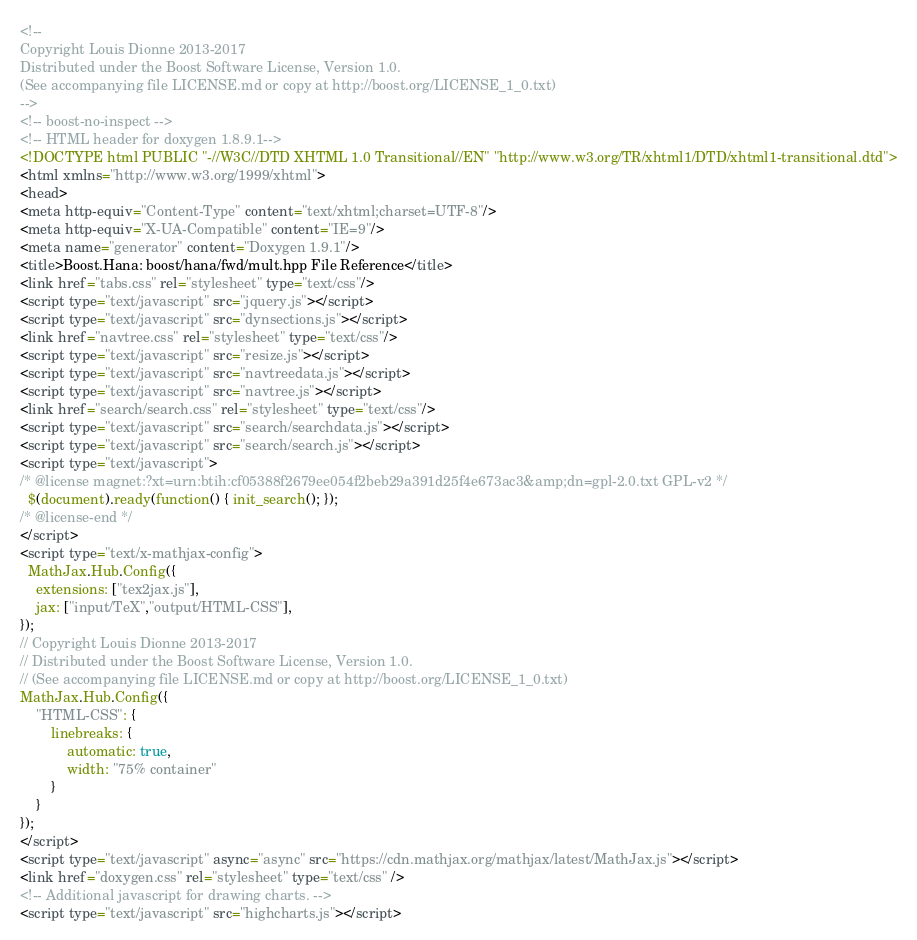<code> <loc_0><loc_0><loc_500><loc_500><_HTML_><!--
Copyright Louis Dionne 2013-2017
Distributed under the Boost Software License, Version 1.0.
(See accompanying file LICENSE.md or copy at http://boost.org/LICENSE_1_0.txt)
-->
<!-- boost-no-inspect -->
<!-- HTML header for doxygen 1.8.9.1-->
<!DOCTYPE html PUBLIC "-//W3C//DTD XHTML 1.0 Transitional//EN" "http://www.w3.org/TR/xhtml1/DTD/xhtml1-transitional.dtd">
<html xmlns="http://www.w3.org/1999/xhtml">
<head>
<meta http-equiv="Content-Type" content="text/xhtml;charset=UTF-8"/>
<meta http-equiv="X-UA-Compatible" content="IE=9"/>
<meta name="generator" content="Doxygen 1.9.1"/>
<title>Boost.Hana: boost/hana/fwd/mult.hpp File Reference</title>
<link href="tabs.css" rel="stylesheet" type="text/css"/>
<script type="text/javascript" src="jquery.js"></script>
<script type="text/javascript" src="dynsections.js"></script>
<link href="navtree.css" rel="stylesheet" type="text/css"/>
<script type="text/javascript" src="resize.js"></script>
<script type="text/javascript" src="navtreedata.js"></script>
<script type="text/javascript" src="navtree.js"></script>
<link href="search/search.css" rel="stylesheet" type="text/css"/>
<script type="text/javascript" src="search/searchdata.js"></script>
<script type="text/javascript" src="search/search.js"></script>
<script type="text/javascript">
/* @license magnet:?xt=urn:btih:cf05388f2679ee054f2beb29a391d25f4e673ac3&amp;dn=gpl-2.0.txt GPL-v2 */
  $(document).ready(function() { init_search(); });
/* @license-end */
</script>
<script type="text/x-mathjax-config">
  MathJax.Hub.Config({
    extensions: ["tex2jax.js"],
    jax: ["input/TeX","output/HTML-CSS"],
});
// Copyright Louis Dionne 2013-2017
// Distributed under the Boost Software License, Version 1.0.
// (See accompanying file LICENSE.md or copy at http://boost.org/LICENSE_1_0.txt)
MathJax.Hub.Config({
    "HTML-CSS": {
        linebreaks: {
            automatic: true,
            width: "75% container"
        }
    }
});
</script>
<script type="text/javascript" async="async" src="https://cdn.mathjax.org/mathjax/latest/MathJax.js"></script>
<link href="doxygen.css" rel="stylesheet" type="text/css" />
<!-- Additional javascript for drawing charts. -->
<script type="text/javascript" src="highcharts.js"></script></code> 